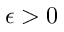Convert formula to latex. <formula><loc_0><loc_0><loc_500><loc_500>\epsilon > 0</formula> 